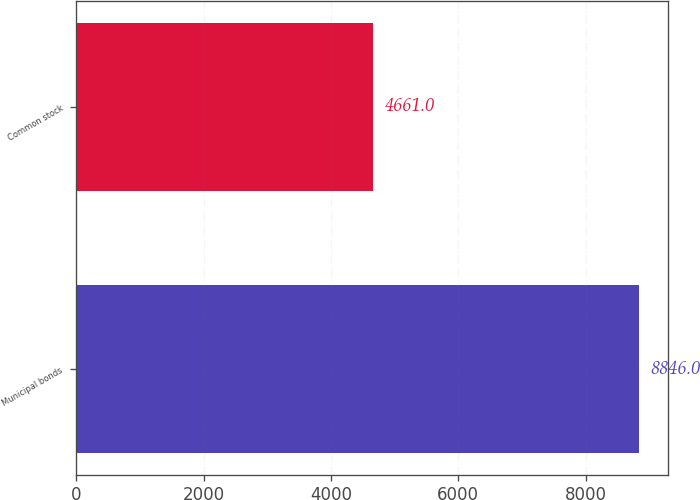Convert chart to OTSL. <chart><loc_0><loc_0><loc_500><loc_500><bar_chart><fcel>Municipal bonds<fcel>Common stock<nl><fcel>8846<fcel>4661<nl></chart> 